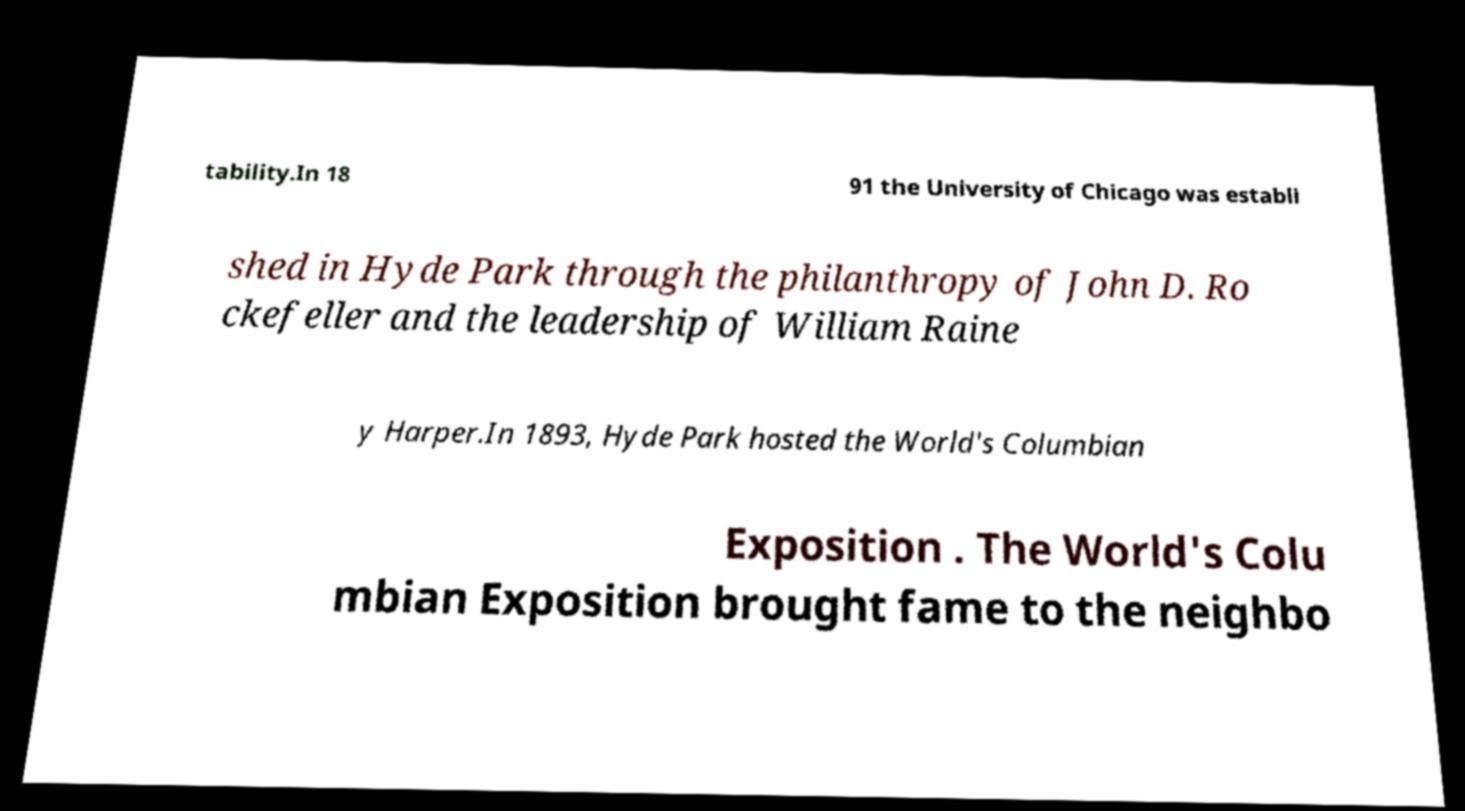Can you read and provide the text displayed in the image?This photo seems to have some interesting text. Can you extract and type it out for me? tability.In 18 91 the University of Chicago was establi shed in Hyde Park through the philanthropy of John D. Ro ckefeller and the leadership of William Raine y Harper.In 1893, Hyde Park hosted the World's Columbian Exposition . The World's Colu mbian Exposition brought fame to the neighbo 